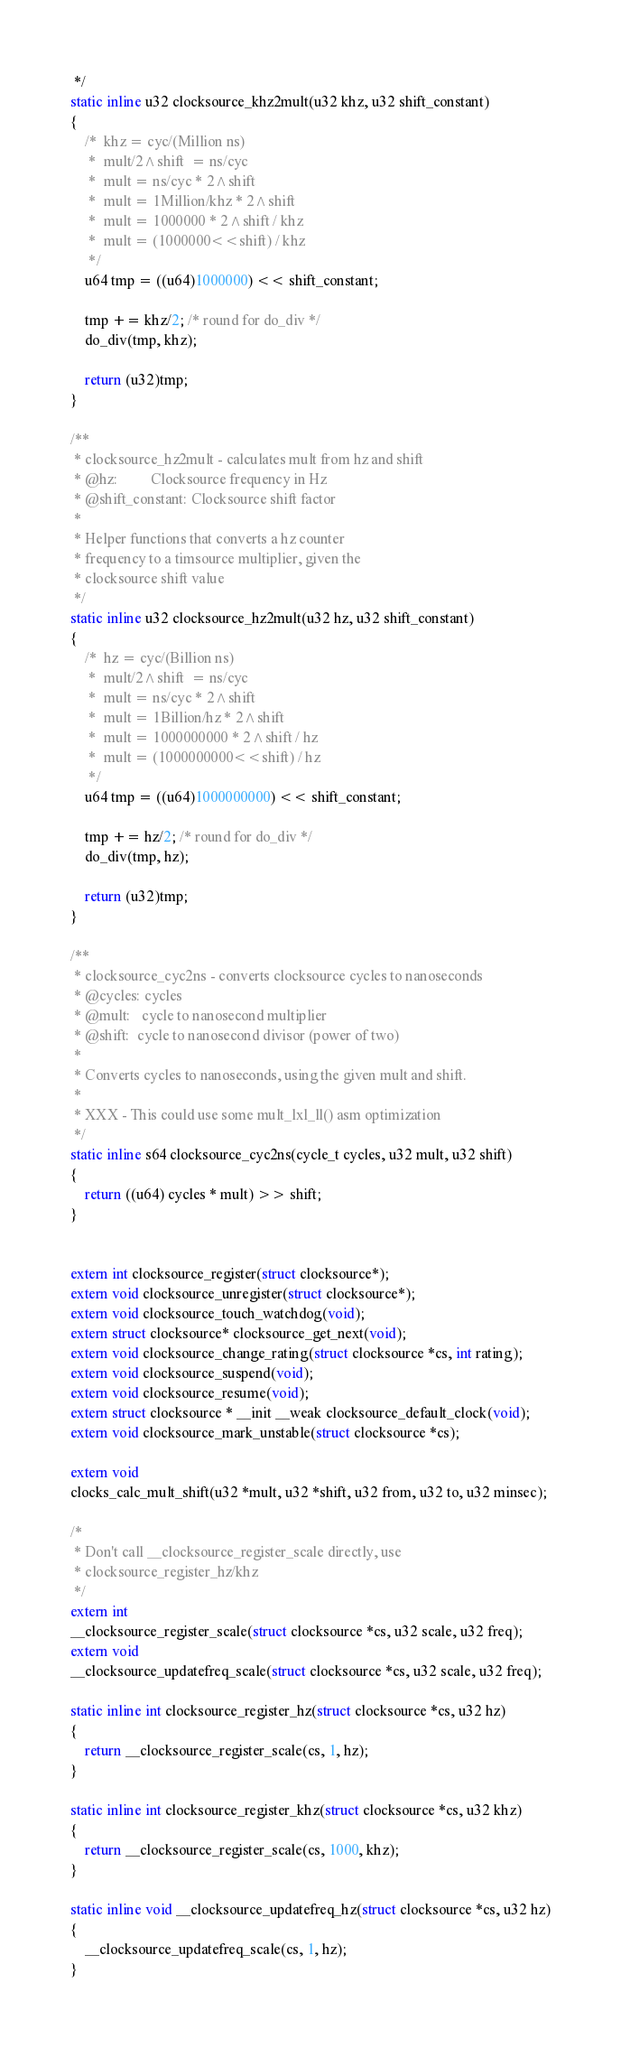<code> <loc_0><loc_0><loc_500><loc_500><_C_> */
static inline u32 clocksource_khz2mult(u32 khz, u32 shift_constant)
{
	/*  khz = cyc/(Million ns)
	 *  mult/2^shift  = ns/cyc
	 *  mult = ns/cyc * 2^shift
	 *  mult = 1Million/khz * 2^shift
	 *  mult = 1000000 * 2^shift / khz
	 *  mult = (1000000<<shift) / khz
	 */
	u64 tmp = ((u64)1000000) << shift_constant;

	tmp += khz/2; /* round for do_div */
	do_div(tmp, khz);

	return (u32)tmp;
}

/**
 * clocksource_hz2mult - calculates mult from hz and shift
 * @hz:			Clocksource frequency in Hz
 * @shift_constant:	Clocksource shift factor
 *
 * Helper functions that converts a hz counter
 * frequency to a timsource multiplier, given the
 * clocksource shift value
 */
static inline u32 clocksource_hz2mult(u32 hz, u32 shift_constant)
{
	/*  hz = cyc/(Billion ns)
	 *  mult/2^shift  = ns/cyc
	 *  mult = ns/cyc * 2^shift
	 *  mult = 1Billion/hz * 2^shift
	 *  mult = 1000000000 * 2^shift / hz
	 *  mult = (1000000000<<shift) / hz
	 */
	u64 tmp = ((u64)1000000000) << shift_constant;

	tmp += hz/2; /* round for do_div */
	do_div(tmp, hz);

	return (u32)tmp;
}

/**
 * clocksource_cyc2ns - converts clocksource cycles to nanoseconds
 * @cycles:	cycles
 * @mult:	cycle to nanosecond multiplier
 * @shift:	cycle to nanosecond divisor (power of two)
 *
 * Converts cycles to nanoseconds, using the given mult and shift.
 *
 * XXX - This could use some mult_lxl_ll() asm optimization
 */
static inline s64 clocksource_cyc2ns(cycle_t cycles, u32 mult, u32 shift)
{
	return ((u64) cycles * mult) >> shift;
}


extern int clocksource_register(struct clocksource*);
extern void clocksource_unregister(struct clocksource*);
extern void clocksource_touch_watchdog(void);
extern struct clocksource* clocksource_get_next(void);
extern void clocksource_change_rating(struct clocksource *cs, int rating);
extern void clocksource_suspend(void);
extern void clocksource_resume(void);
extern struct clocksource * __init __weak clocksource_default_clock(void);
extern void clocksource_mark_unstable(struct clocksource *cs);

extern void
clocks_calc_mult_shift(u32 *mult, u32 *shift, u32 from, u32 to, u32 minsec);

/*
 * Don't call __clocksource_register_scale directly, use
 * clocksource_register_hz/khz
 */
extern int
__clocksource_register_scale(struct clocksource *cs, u32 scale, u32 freq);
extern void
__clocksource_updatefreq_scale(struct clocksource *cs, u32 scale, u32 freq);

static inline int clocksource_register_hz(struct clocksource *cs, u32 hz)
{
	return __clocksource_register_scale(cs, 1, hz);
}

static inline int clocksource_register_khz(struct clocksource *cs, u32 khz)
{
	return __clocksource_register_scale(cs, 1000, khz);
}

static inline void __clocksource_updatefreq_hz(struct clocksource *cs, u32 hz)
{
	__clocksource_updatefreq_scale(cs, 1, hz);
}
</code> 